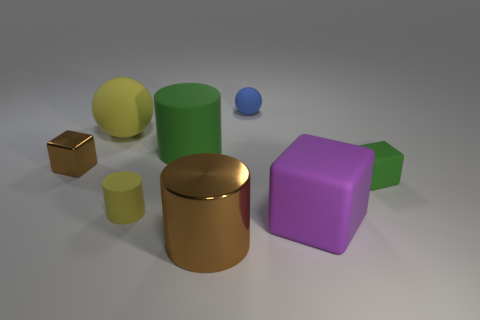How many rubber things are there? 6 